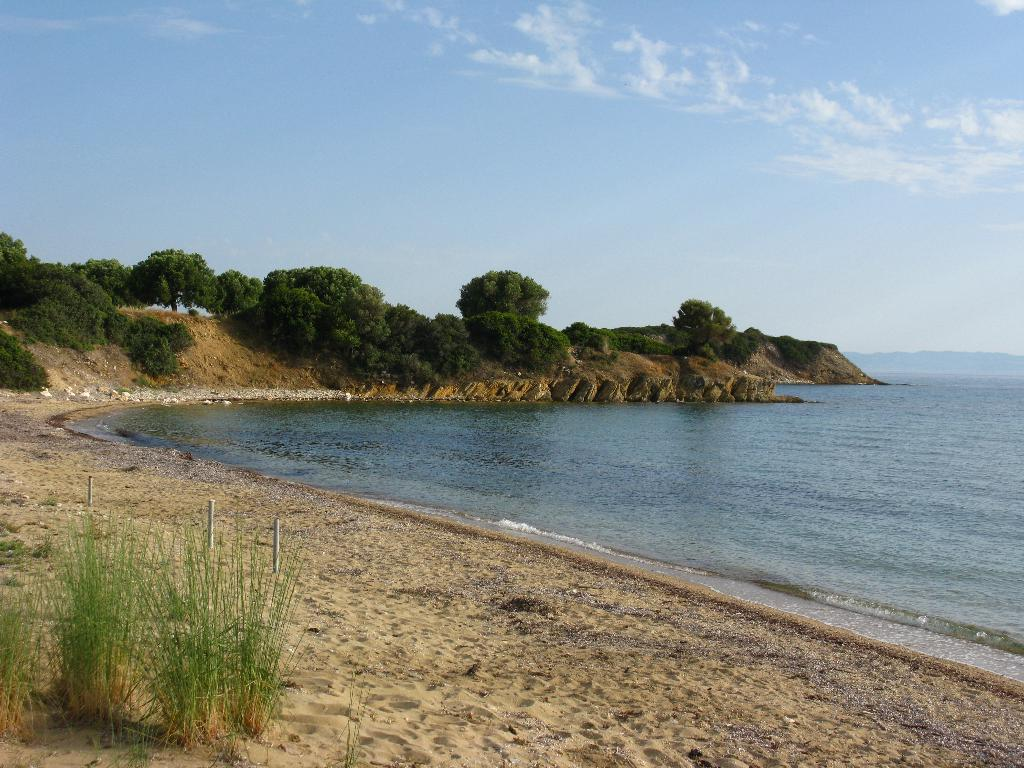What type of terrain is visible in the image? There is grass and sand visible in the image. What structures can be seen in the image? There are poles in the image. What natural elements are present in the image? There is water visible in the image, as well as trees and the sky in the background. What is the condition of the sky in the image? The sky is visible in the background of the image, and clouds are present. What type of tank is visible in the image? There is no tank present in the image. What is the interest rate for the loan mentioned in the image? There is no mention of a loan or interest rate in the image. 